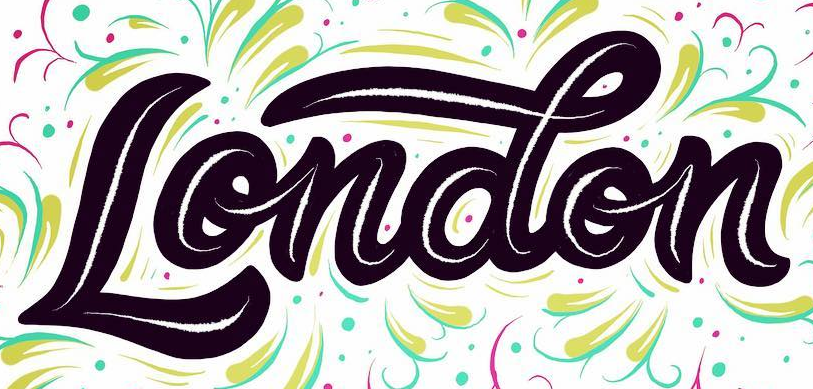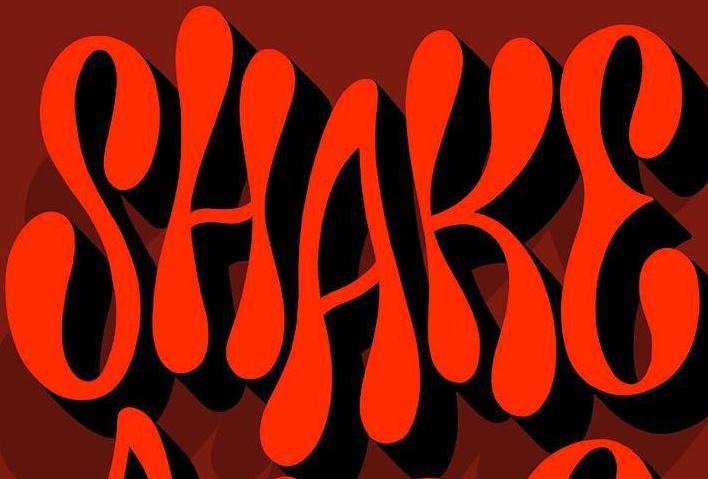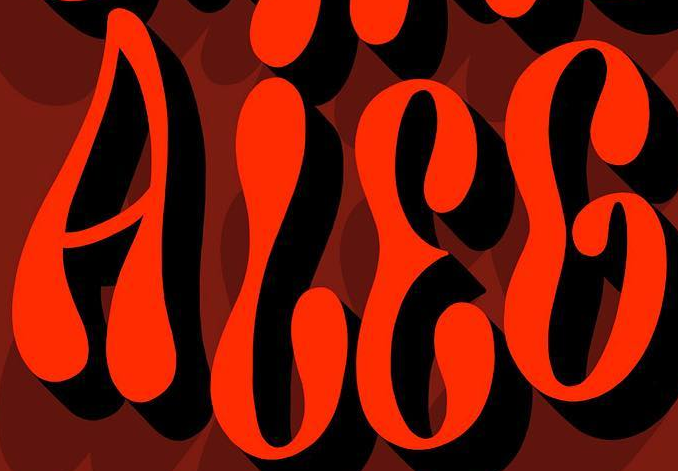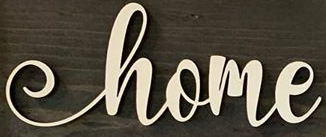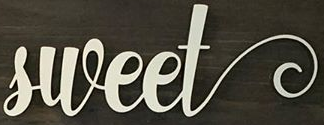Read the text from these images in sequence, separated by a semicolon. London; SHAKE; ALEG; home; sweet 